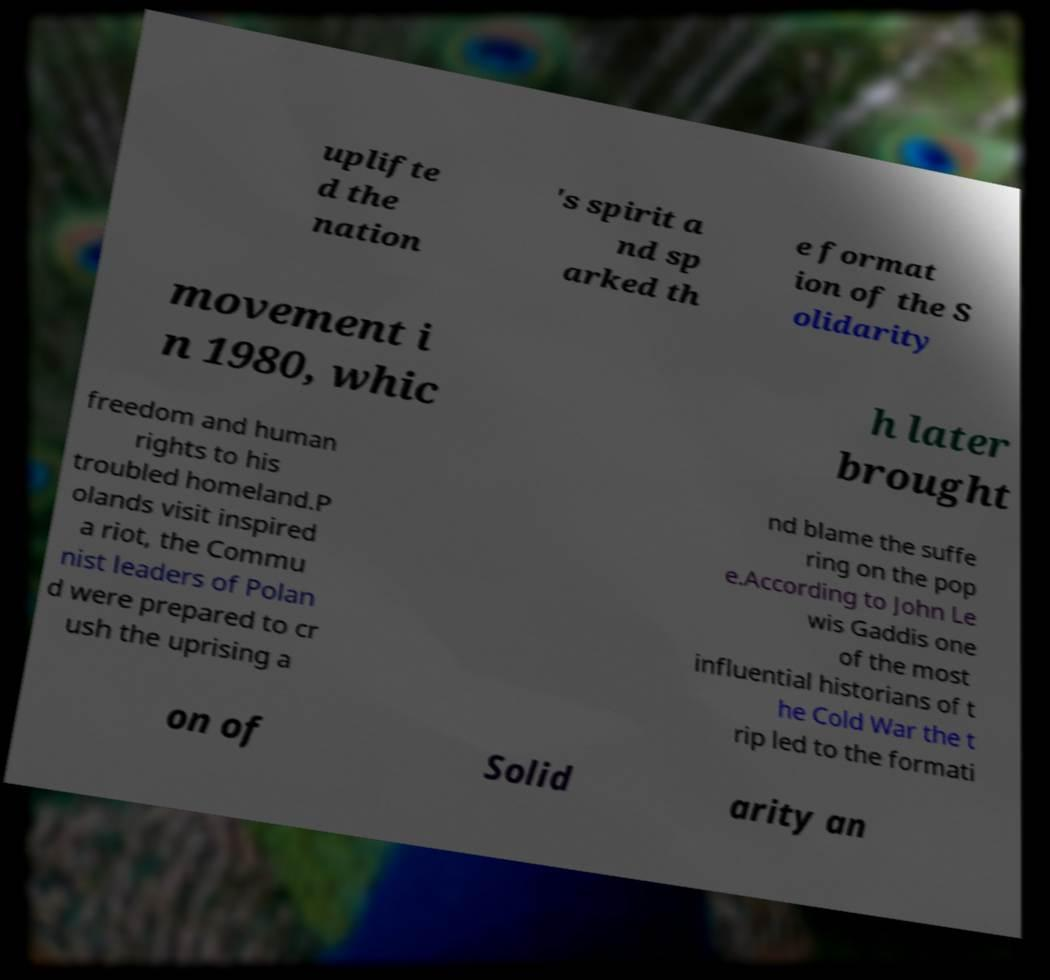Please read and relay the text visible in this image. What does it say? uplifte d the nation 's spirit a nd sp arked th e format ion of the S olidarity movement i n 1980, whic h later brought freedom and human rights to his troubled homeland.P olands visit inspired a riot, the Commu nist leaders of Polan d were prepared to cr ush the uprising a nd blame the suffe ring on the pop e.According to John Le wis Gaddis one of the most influential historians of t he Cold War the t rip led to the formati on of Solid arity an 